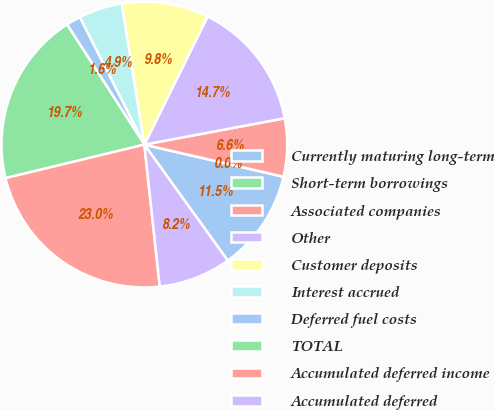Convert chart. <chart><loc_0><loc_0><loc_500><loc_500><pie_chart><fcel>Currently maturing long-term<fcel>Short-term borrowings<fcel>Associated companies<fcel>Other<fcel>Customer deposits<fcel>Interest accrued<fcel>Deferred fuel costs<fcel>TOTAL<fcel>Accumulated deferred income<fcel>Accumulated deferred<nl><fcel>11.47%<fcel>0.0%<fcel>6.56%<fcel>14.75%<fcel>9.84%<fcel>4.92%<fcel>1.64%<fcel>19.67%<fcel>22.95%<fcel>8.2%<nl></chart> 